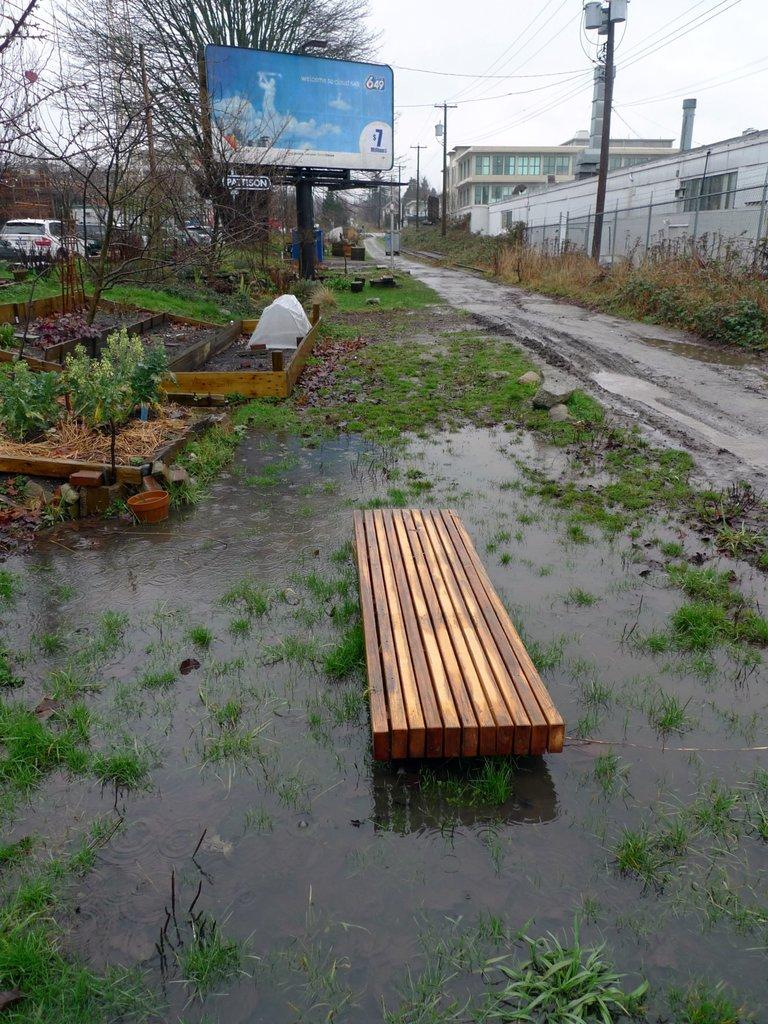What is located in the water in the image? There is a bench in the water in the image. What is positioned beside a tree in the image? There is a board beside a tree in the image. What can be seen in the top right of the image? There are buildings in the top right of the image. What is visible at the top of the image? The sky is visible at the top of the image. Who is the owner of the respect shown in the image? There is no indication of respect or an owner in the image. How does the balance of the bench in the water affect the overall composition of the image? The image does not show the bench in the water as being unbalanced, so it does not affect the overall composition in that way. 